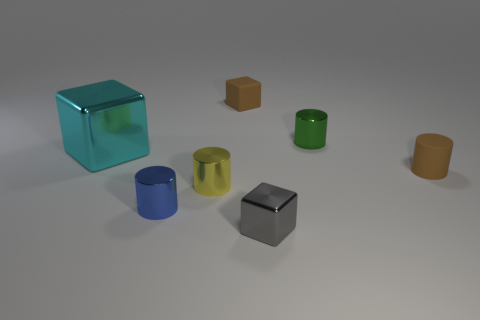Is there any other thing that has the same color as the tiny rubber cylinder?
Provide a succinct answer. Yes. There is a small yellow thing that is the same shape as the tiny green thing; what is it made of?
Your answer should be compact. Metal. How many other objects are the same size as the blue cylinder?
Your answer should be very brief. 5. There is a rubber object that is the same color as the tiny matte cube; what is its size?
Make the answer very short. Small. There is a tiny rubber thing that is left of the tiny gray metal cube; does it have the same shape as the green shiny object?
Keep it short and to the point. No. How many other things are the same shape as the small yellow shiny object?
Your response must be concise. 3. There is a shiny object that is behind the big cyan cube; what shape is it?
Offer a terse response. Cylinder. Is there a small brown thing made of the same material as the green cylinder?
Offer a terse response. No. Is the color of the cylinder behind the cyan metallic cube the same as the small matte cylinder?
Keep it short and to the point. No. What size is the green cylinder?
Give a very brief answer. Small. 